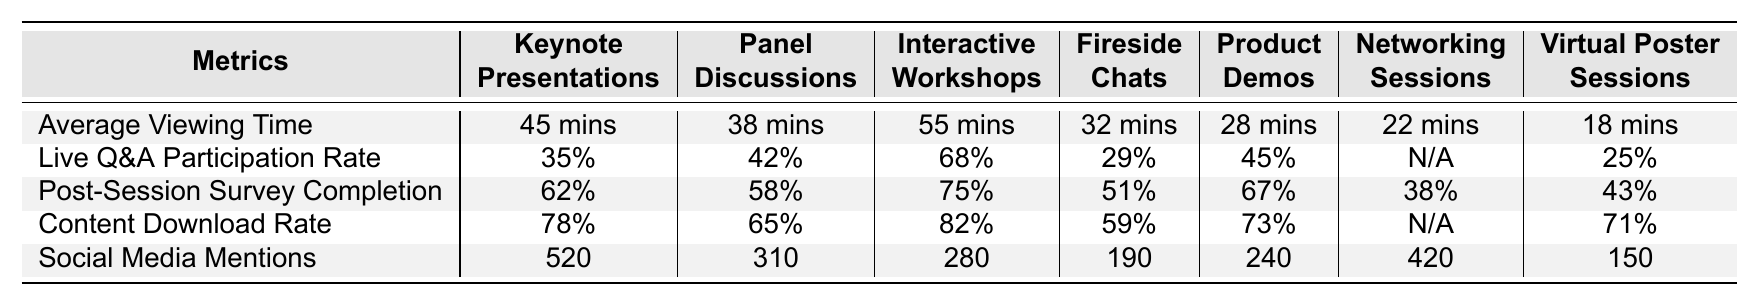What is the average viewing time for Interactive Workshops? In the table, the row labeled "Average Viewing Time" for "Interactive Workshops" shows "55 minutes".
Answer: 55 minutes Which session format has the highest Live Q&A Participation Rate? By comparing the Live Q&A Participation Rate across all formats, Interactive Workshops has the highest rate at "68%".
Answer: Interactive Workshops How many Social Media Mentions did Keynote Presentations receive? The row for "Social Media Mentions" indicates that Keynote Presentations received "520" mentions.
Answer: 520 What is the difference in Post-Session Survey Completion between Keynote Presentations and Fireside Chats? From the table, Keynote Presentations has a completion rate of "62%", while Fireside Chats has "51%". The difference is 62% - 51% = 11%.
Answer: 11% Is the Content Download Rate for Networking Sessions available? The row for "Content Download Rate" shows "N/A" for Networking Sessions, indicating no data available.
Answer: No How does the Average Viewing Time of Panel Discussions compare to that of Product Demos? Panel Discussions have an Average Viewing Time of "38 minutes" and Product Demos have "28 minutes". The difference is 38 minutes - 28 minutes = 10 minutes.
Answer: 10 minutes Which session format has the lowest Social Media Mentions? The Social Media Mentions for each format show that Virtual Poster Sessions has the lowest at "150".
Answer: Virtual Poster Sessions Calculate the average Content Download Rate for Keynote Presentations, Panel Discussions, and Interactive Workshops. The Content Download Rates are 78% for Keynote, 65% for Panel, and 82% for Workshops. Adding these: 78% + 65% + 82% = 225%. Dividing by 3 gives an average of 225% / 3 = 75%.
Answer: 75% What percentage of attendees completed the Post-Session Survey for Fireside Chats? For Fireside Chats, the Post-Session Survey Completion is listed as "51%".
Answer: 51% Do all session formats have a Live Q&A Participation Rate? Reviewing the table, Networking Sessions lists "N/A" under Live Q&A Participation Rate, indicating it does not have this data.
Answer: No 